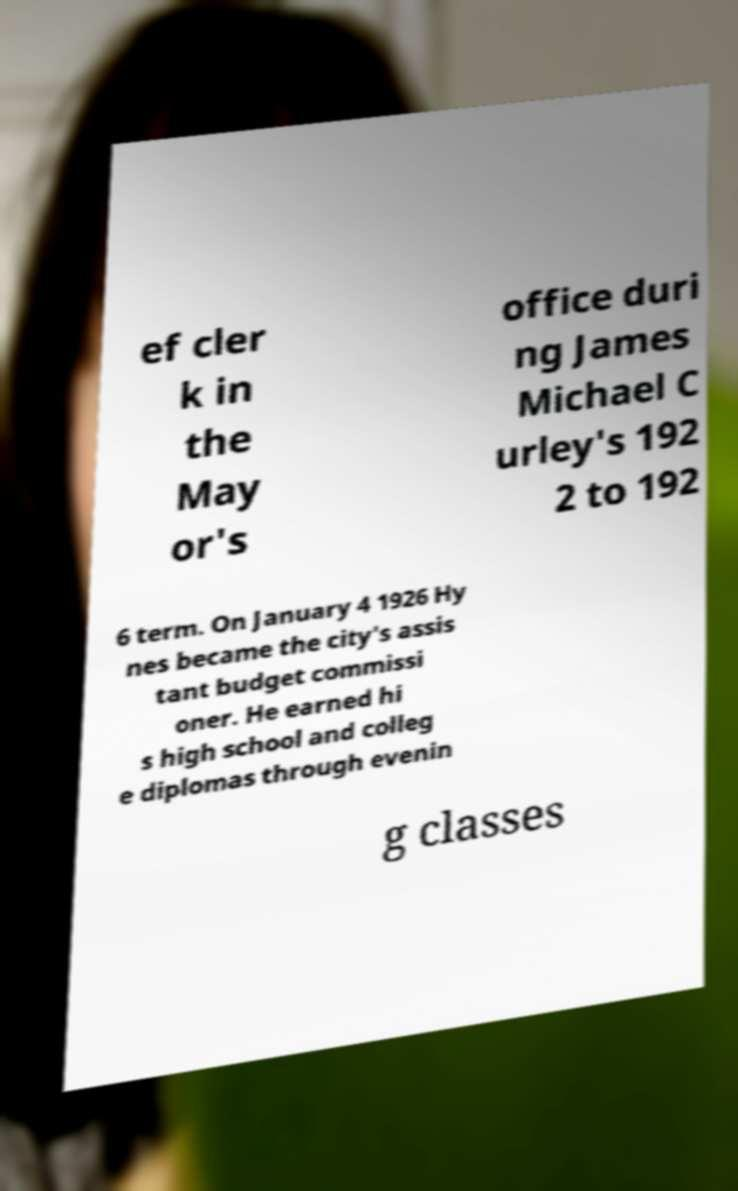Please read and relay the text visible in this image. What does it say? ef cler k in the May or's office duri ng James Michael C urley's 192 2 to 192 6 term. On January 4 1926 Hy nes became the city's assis tant budget commissi oner. He earned hi s high school and colleg e diplomas through evenin g classes 